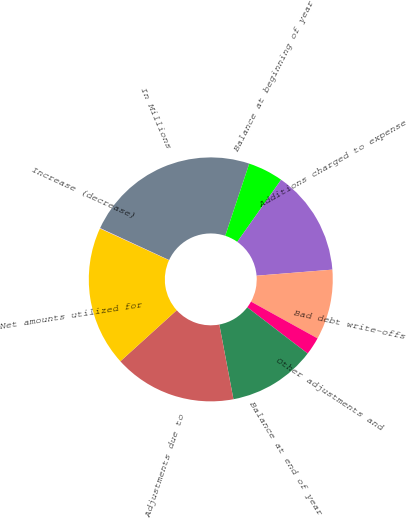Convert chart to OTSL. <chart><loc_0><loc_0><loc_500><loc_500><pie_chart><fcel>In Millions<fcel>Balance at beginning of year<fcel>Additions charged to expense<fcel>Bad debt write-offs<fcel>Other adjustments and<fcel>Balance at end of year<fcel>Adjustments due to<fcel>Net amounts utilized for<fcel>Increase (decrease)<nl><fcel>23.2%<fcel>4.68%<fcel>13.94%<fcel>9.31%<fcel>2.36%<fcel>11.63%<fcel>16.26%<fcel>18.57%<fcel>0.05%<nl></chart> 